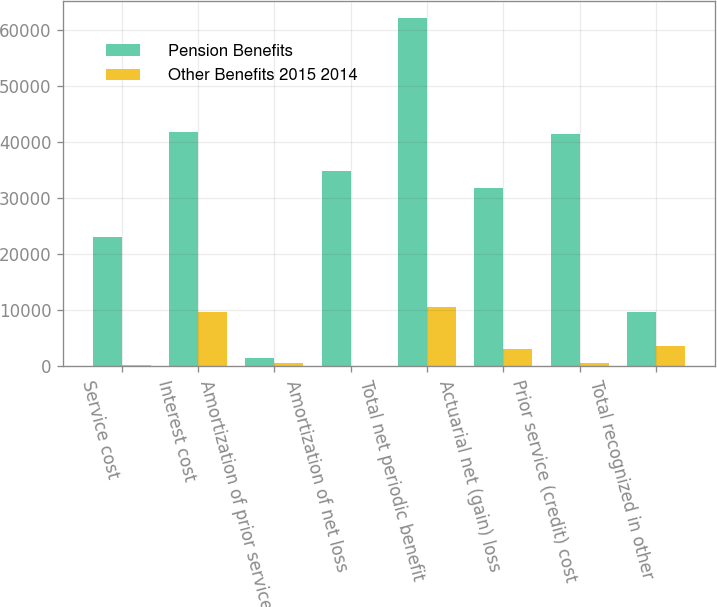Convert chart to OTSL. <chart><loc_0><loc_0><loc_500><loc_500><stacked_bar_chart><ecel><fcel>Service cost<fcel>Interest cost<fcel>Amortization of prior service<fcel>Amortization of net loss<fcel>Total net periodic benefit<fcel>Actuarial net (gain) loss<fcel>Prior service (credit) cost<fcel>Total recognized in other<nl><fcel>Pension Benefits<fcel>23075<fcel>41875<fcel>1555<fcel>34940<fcel>62172<fcel>31772<fcel>41517<fcel>9731<nl><fcel>Other Benefits 2015 2014<fcel>299<fcel>9731<fcel>575<fcel>13<fcel>10592<fcel>3047<fcel>572<fcel>3619<nl></chart> 